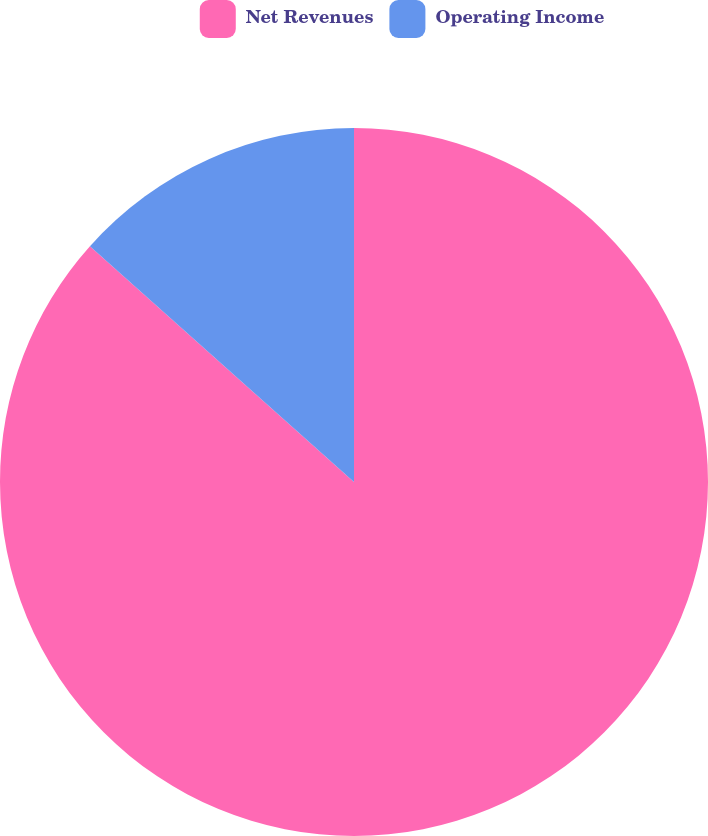<chart> <loc_0><loc_0><loc_500><loc_500><pie_chart><fcel>Net Revenues<fcel>Operating Income<nl><fcel>86.6%<fcel>13.4%<nl></chart> 